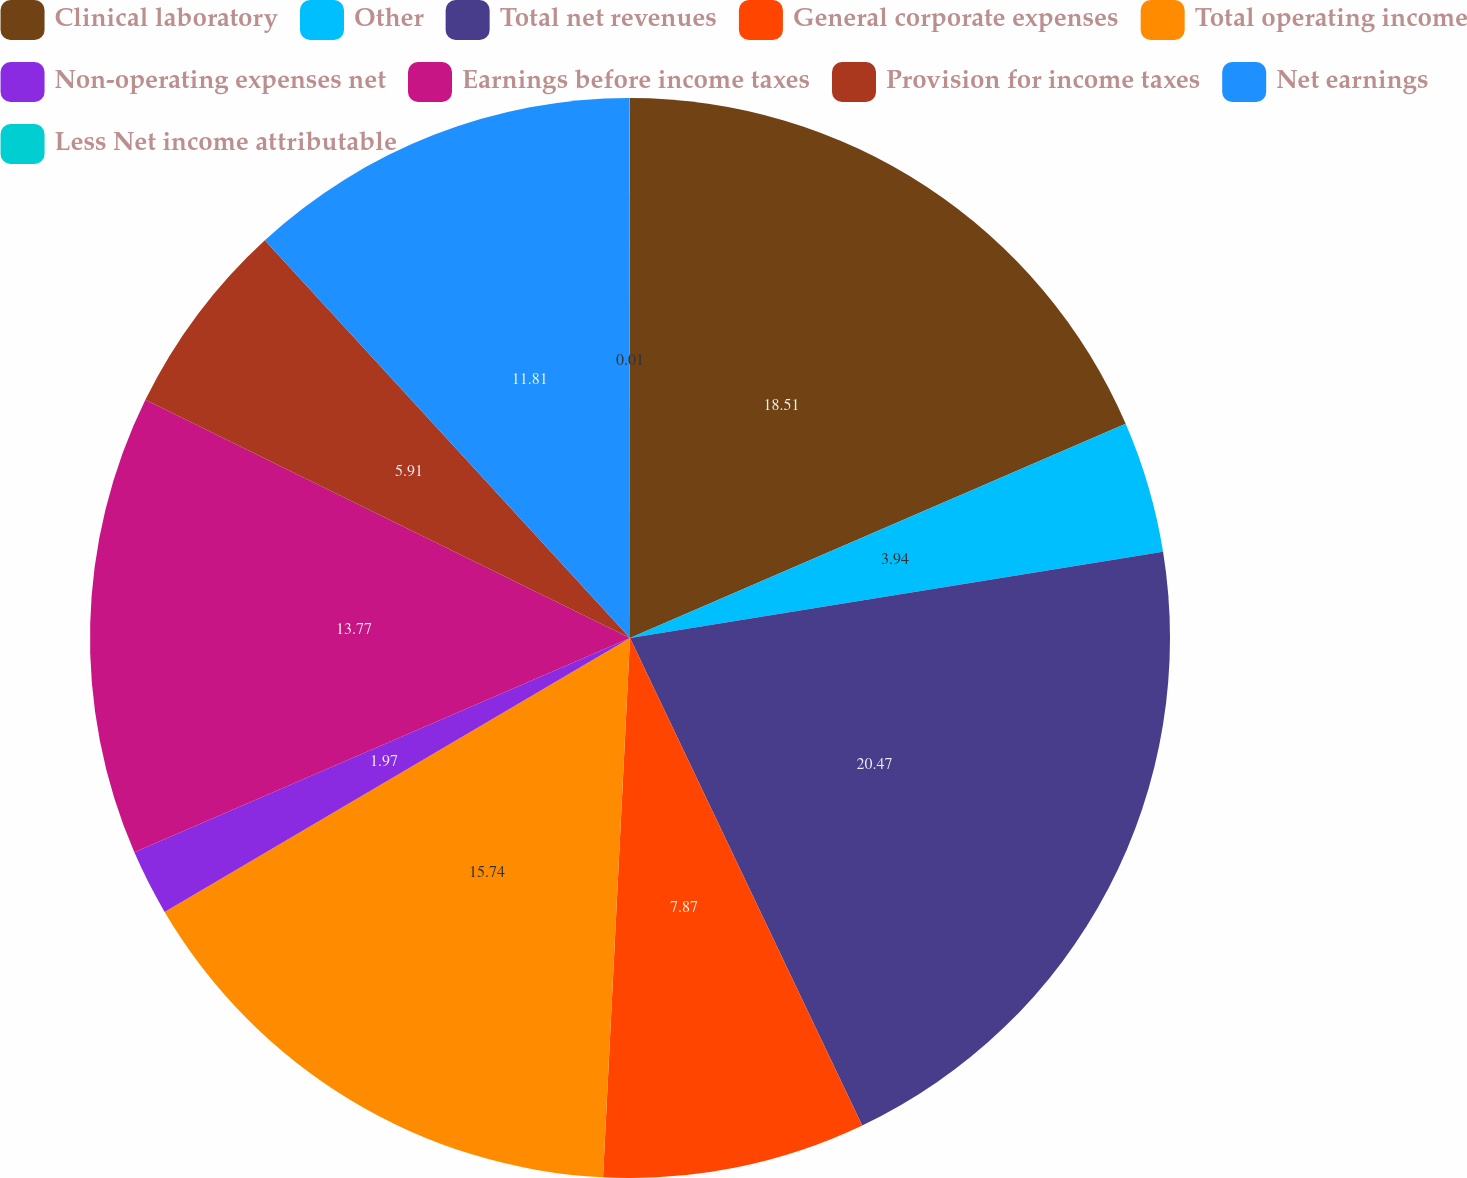<chart> <loc_0><loc_0><loc_500><loc_500><pie_chart><fcel>Clinical laboratory<fcel>Other<fcel>Total net revenues<fcel>General corporate expenses<fcel>Total operating income<fcel>Non-operating expenses net<fcel>Earnings before income taxes<fcel>Provision for income taxes<fcel>Net earnings<fcel>Less Net income attributable<nl><fcel>18.51%<fcel>3.94%<fcel>20.48%<fcel>7.87%<fcel>15.74%<fcel>1.97%<fcel>13.77%<fcel>5.91%<fcel>11.81%<fcel>0.01%<nl></chart> 